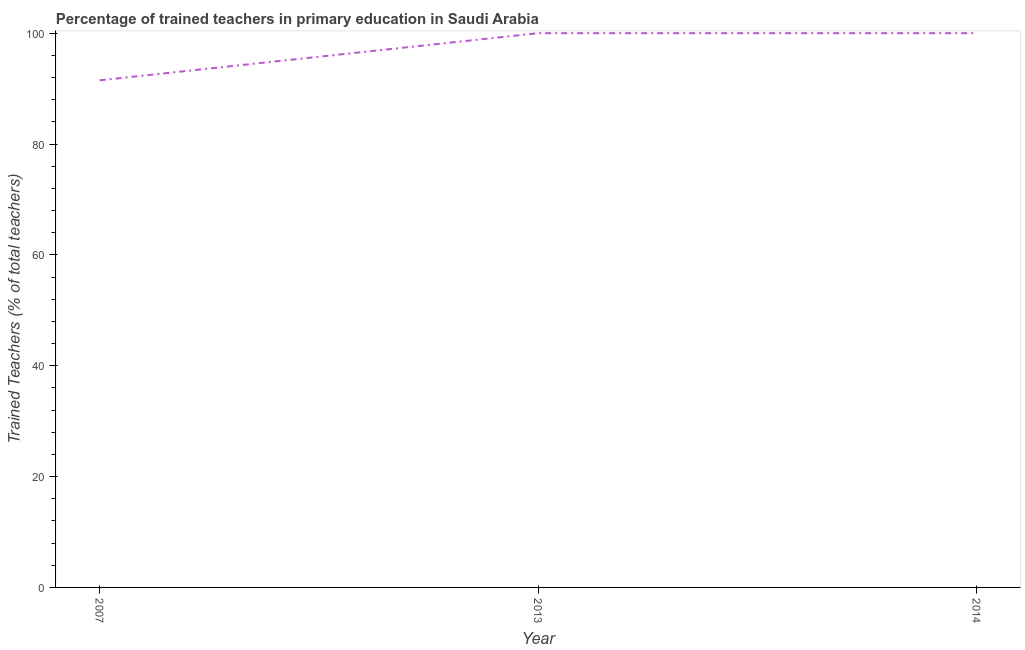Across all years, what is the minimum percentage of trained teachers?
Ensure brevity in your answer.  91.5. In which year was the percentage of trained teachers maximum?
Ensure brevity in your answer.  2013. What is the sum of the percentage of trained teachers?
Your answer should be very brief. 291.5. What is the difference between the percentage of trained teachers in 2007 and 2014?
Offer a very short reply. -8.5. What is the average percentage of trained teachers per year?
Provide a succinct answer. 97.17. What is the median percentage of trained teachers?
Give a very brief answer. 100. In how many years, is the percentage of trained teachers greater than 52 %?
Your answer should be compact. 3. Do a majority of the years between 2007 and 2014 (inclusive) have percentage of trained teachers greater than 32 %?
Provide a succinct answer. Yes. What is the ratio of the percentage of trained teachers in 2007 to that in 2014?
Ensure brevity in your answer.  0.91. What is the difference between the highest and the second highest percentage of trained teachers?
Your answer should be compact. 0. Is the sum of the percentage of trained teachers in 2007 and 2014 greater than the maximum percentage of trained teachers across all years?
Offer a terse response. Yes. What is the difference between the highest and the lowest percentage of trained teachers?
Your response must be concise. 8.5. In how many years, is the percentage of trained teachers greater than the average percentage of trained teachers taken over all years?
Offer a very short reply. 2. Does the percentage of trained teachers monotonically increase over the years?
Your answer should be compact. No. How many years are there in the graph?
Your answer should be very brief. 3. What is the difference between two consecutive major ticks on the Y-axis?
Make the answer very short. 20. Does the graph contain any zero values?
Your answer should be very brief. No. Does the graph contain grids?
Provide a short and direct response. No. What is the title of the graph?
Ensure brevity in your answer.  Percentage of trained teachers in primary education in Saudi Arabia. What is the label or title of the Y-axis?
Provide a succinct answer. Trained Teachers (% of total teachers). What is the Trained Teachers (% of total teachers) in 2007?
Provide a succinct answer. 91.5. What is the Trained Teachers (% of total teachers) of 2013?
Offer a very short reply. 100. What is the difference between the Trained Teachers (% of total teachers) in 2007 and 2013?
Provide a succinct answer. -8.5. What is the difference between the Trained Teachers (% of total teachers) in 2007 and 2014?
Provide a succinct answer. -8.5. What is the ratio of the Trained Teachers (% of total teachers) in 2007 to that in 2013?
Your response must be concise. 0.92. What is the ratio of the Trained Teachers (% of total teachers) in 2007 to that in 2014?
Offer a terse response. 0.92. What is the ratio of the Trained Teachers (% of total teachers) in 2013 to that in 2014?
Provide a succinct answer. 1. 